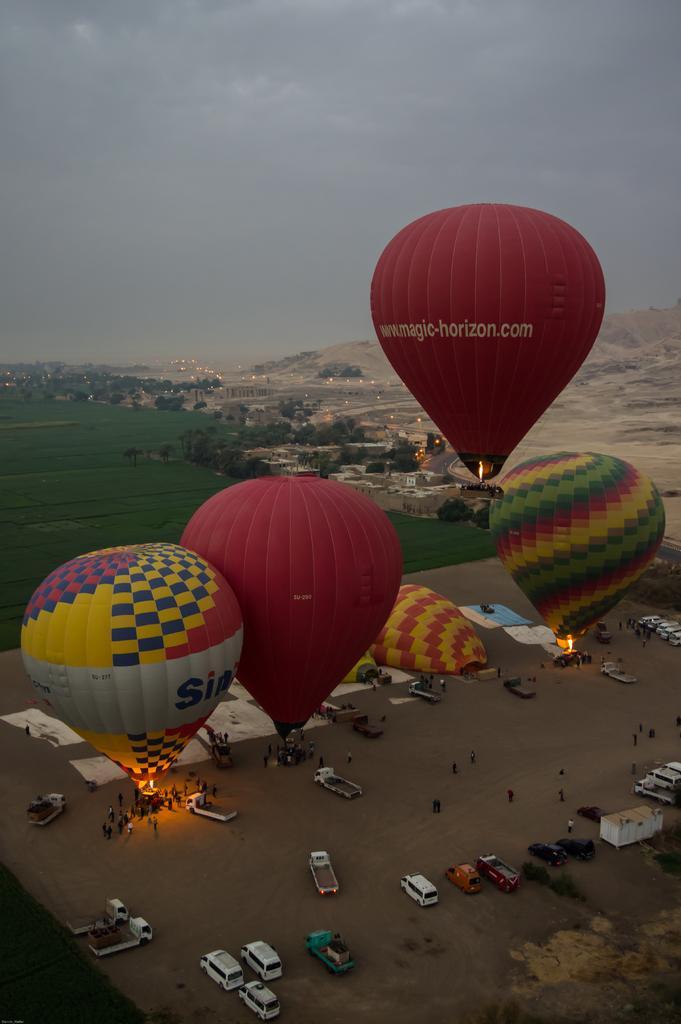In one or two sentences, can you explain what this image depicts? In the middle I can see parachutes, lamps, grass. In the background I can see fleets of vehicles on the road, crowd, mountains, trees, houses, buildings, lights, water and the sky. This image is taken may be in the evening. 